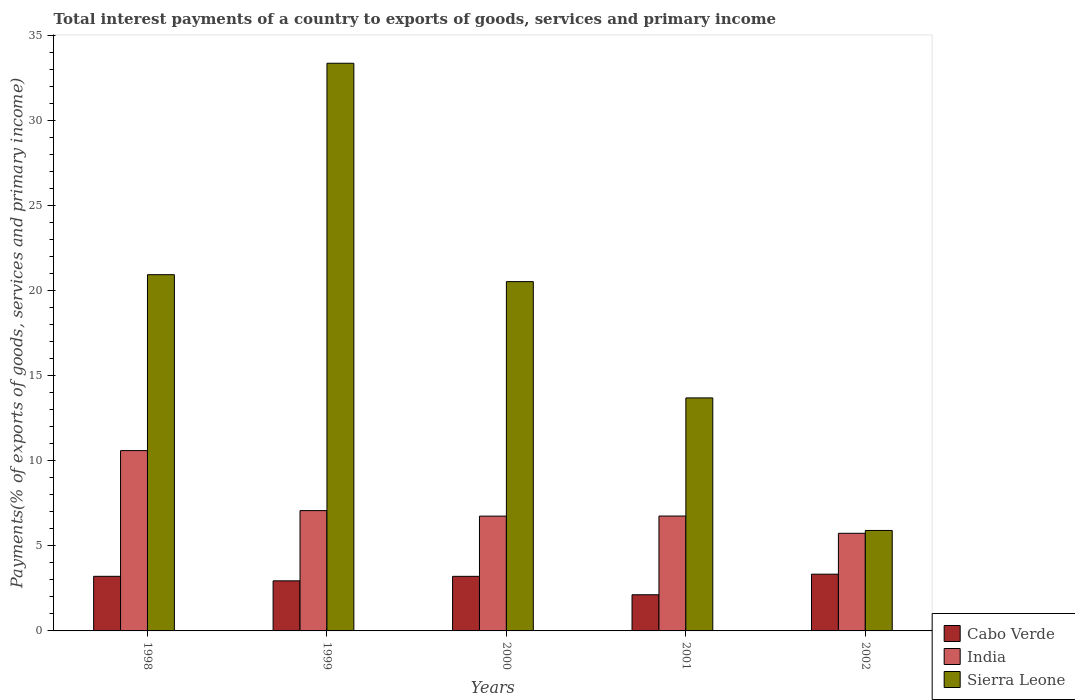How many different coloured bars are there?
Your answer should be very brief. 3. Are the number of bars per tick equal to the number of legend labels?
Ensure brevity in your answer.  Yes. Are the number of bars on each tick of the X-axis equal?
Provide a succinct answer. Yes. How many bars are there on the 3rd tick from the left?
Offer a very short reply. 3. How many bars are there on the 4th tick from the right?
Your answer should be very brief. 3. What is the total interest payments in Cabo Verde in 2002?
Your response must be concise. 3.34. Across all years, what is the maximum total interest payments in India?
Provide a succinct answer. 10.61. Across all years, what is the minimum total interest payments in India?
Your answer should be very brief. 5.74. In which year was the total interest payments in Sierra Leone maximum?
Your answer should be compact. 1999. In which year was the total interest payments in Sierra Leone minimum?
Make the answer very short. 2002. What is the total total interest payments in Sierra Leone in the graph?
Offer a very short reply. 94.5. What is the difference between the total interest payments in India in 2000 and that in 2002?
Offer a terse response. 1.01. What is the difference between the total interest payments in India in 2000 and the total interest payments in Cabo Verde in 1999?
Your answer should be very brief. 3.81. What is the average total interest payments in India per year?
Ensure brevity in your answer.  7.39. In the year 2001, what is the difference between the total interest payments in Sierra Leone and total interest payments in India?
Provide a short and direct response. 6.95. What is the ratio of the total interest payments in India in 2000 to that in 2002?
Provide a succinct answer. 1.18. What is the difference between the highest and the second highest total interest payments in Cabo Verde?
Ensure brevity in your answer.  0.13. What is the difference between the highest and the lowest total interest payments in Cabo Verde?
Your answer should be compact. 1.21. In how many years, is the total interest payments in Cabo Verde greater than the average total interest payments in Cabo Verde taken over all years?
Your answer should be very brief. 3. What does the 1st bar from the left in 1998 represents?
Offer a terse response. Cabo Verde. What does the 3rd bar from the right in 2001 represents?
Ensure brevity in your answer.  Cabo Verde. How many bars are there?
Ensure brevity in your answer.  15. Are all the bars in the graph horizontal?
Offer a terse response. No. How many years are there in the graph?
Ensure brevity in your answer.  5. What is the difference between two consecutive major ticks on the Y-axis?
Your answer should be very brief. 5. How are the legend labels stacked?
Give a very brief answer. Vertical. What is the title of the graph?
Provide a short and direct response. Total interest payments of a country to exports of goods, services and primary income. Does "Europe(developing only)" appear as one of the legend labels in the graph?
Make the answer very short. No. What is the label or title of the Y-axis?
Offer a very short reply. Payments(% of exports of goods, services and primary income). What is the Payments(% of exports of goods, services and primary income) in Cabo Verde in 1998?
Ensure brevity in your answer.  3.21. What is the Payments(% of exports of goods, services and primary income) in India in 1998?
Ensure brevity in your answer.  10.61. What is the Payments(% of exports of goods, services and primary income) in Sierra Leone in 1998?
Your answer should be very brief. 20.95. What is the Payments(% of exports of goods, services and primary income) of Cabo Verde in 1999?
Make the answer very short. 2.95. What is the Payments(% of exports of goods, services and primary income) of India in 1999?
Your response must be concise. 7.08. What is the Payments(% of exports of goods, services and primary income) of Sierra Leone in 1999?
Your response must be concise. 33.39. What is the Payments(% of exports of goods, services and primary income) in Cabo Verde in 2000?
Ensure brevity in your answer.  3.21. What is the Payments(% of exports of goods, services and primary income) in India in 2000?
Make the answer very short. 6.75. What is the Payments(% of exports of goods, services and primary income) of Sierra Leone in 2000?
Provide a short and direct response. 20.55. What is the Payments(% of exports of goods, services and primary income) of Cabo Verde in 2001?
Your answer should be compact. 2.13. What is the Payments(% of exports of goods, services and primary income) in India in 2001?
Your response must be concise. 6.76. What is the Payments(% of exports of goods, services and primary income) in Sierra Leone in 2001?
Your answer should be compact. 13.71. What is the Payments(% of exports of goods, services and primary income) of Cabo Verde in 2002?
Give a very brief answer. 3.34. What is the Payments(% of exports of goods, services and primary income) in India in 2002?
Provide a short and direct response. 5.74. What is the Payments(% of exports of goods, services and primary income) of Sierra Leone in 2002?
Give a very brief answer. 5.91. Across all years, what is the maximum Payments(% of exports of goods, services and primary income) in Cabo Verde?
Provide a succinct answer. 3.34. Across all years, what is the maximum Payments(% of exports of goods, services and primary income) of India?
Keep it short and to the point. 10.61. Across all years, what is the maximum Payments(% of exports of goods, services and primary income) of Sierra Leone?
Ensure brevity in your answer.  33.39. Across all years, what is the minimum Payments(% of exports of goods, services and primary income) of Cabo Verde?
Offer a terse response. 2.13. Across all years, what is the minimum Payments(% of exports of goods, services and primary income) in India?
Your answer should be very brief. 5.74. Across all years, what is the minimum Payments(% of exports of goods, services and primary income) of Sierra Leone?
Give a very brief answer. 5.91. What is the total Payments(% of exports of goods, services and primary income) in Cabo Verde in the graph?
Your response must be concise. 14.83. What is the total Payments(% of exports of goods, services and primary income) in India in the graph?
Provide a succinct answer. 36.94. What is the total Payments(% of exports of goods, services and primary income) in Sierra Leone in the graph?
Make the answer very short. 94.5. What is the difference between the Payments(% of exports of goods, services and primary income) in Cabo Verde in 1998 and that in 1999?
Your answer should be compact. 0.27. What is the difference between the Payments(% of exports of goods, services and primary income) of India in 1998 and that in 1999?
Your answer should be compact. 3.53. What is the difference between the Payments(% of exports of goods, services and primary income) in Sierra Leone in 1998 and that in 1999?
Provide a succinct answer. -12.44. What is the difference between the Payments(% of exports of goods, services and primary income) in Cabo Verde in 1998 and that in 2000?
Your answer should be very brief. 0. What is the difference between the Payments(% of exports of goods, services and primary income) in India in 1998 and that in 2000?
Make the answer very short. 3.85. What is the difference between the Payments(% of exports of goods, services and primary income) of Sierra Leone in 1998 and that in 2000?
Offer a very short reply. 0.41. What is the difference between the Payments(% of exports of goods, services and primary income) in Cabo Verde in 1998 and that in 2001?
Give a very brief answer. 1.08. What is the difference between the Payments(% of exports of goods, services and primary income) of India in 1998 and that in 2001?
Provide a short and direct response. 3.85. What is the difference between the Payments(% of exports of goods, services and primary income) in Sierra Leone in 1998 and that in 2001?
Your answer should be compact. 7.25. What is the difference between the Payments(% of exports of goods, services and primary income) in Cabo Verde in 1998 and that in 2002?
Provide a short and direct response. -0.13. What is the difference between the Payments(% of exports of goods, services and primary income) in India in 1998 and that in 2002?
Provide a succinct answer. 4.86. What is the difference between the Payments(% of exports of goods, services and primary income) in Sierra Leone in 1998 and that in 2002?
Give a very brief answer. 15.05. What is the difference between the Payments(% of exports of goods, services and primary income) in Cabo Verde in 1999 and that in 2000?
Offer a very short reply. -0.26. What is the difference between the Payments(% of exports of goods, services and primary income) in India in 1999 and that in 2000?
Provide a succinct answer. 0.32. What is the difference between the Payments(% of exports of goods, services and primary income) in Sierra Leone in 1999 and that in 2000?
Provide a succinct answer. 12.84. What is the difference between the Payments(% of exports of goods, services and primary income) of Cabo Verde in 1999 and that in 2001?
Offer a terse response. 0.82. What is the difference between the Payments(% of exports of goods, services and primary income) in India in 1999 and that in 2001?
Give a very brief answer. 0.32. What is the difference between the Payments(% of exports of goods, services and primary income) in Sierra Leone in 1999 and that in 2001?
Your answer should be compact. 19.68. What is the difference between the Payments(% of exports of goods, services and primary income) in Cabo Verde in 1999 and that in 2002?
Your answer should be compact. -0.39. What is the difference between the Payments(% of exports of goods, services and primary income) of India in 1999 and that in 2002?
Provide a succinct answer. 1.33. What is the difference between the Payments(% of exports of goods, services and primary income) of Sierra Leone in 1999 and that in 2002?
Offer a very short reply. 27.48. What is the difference between the Payments(% of exports of goods, services and primary income) in Cabo Verde in 2000 and that in 2001?
Your answer should be very brief. 1.08. What is the difference between the Payments(% of exports of goods, services and primary income) of India in 2000 and that in 2001?
Make the answer very short. -0.01. What is the difference between the Payments(% of exports of goods, services and primary income) in Sierra Leone in 2000 and that in 2001?
Offer a very short reply. 6.84. What is the difference between the Payments(% of exports of goods, services and primary income) of Cabo Verde in 2000 and that in 2002?
Ensure brevity in your answer.  -0.13. What is the difference between the Payments(% of exports of goods, services and primary income) of Sierra Leone in 2000 and that in 2002?
Your response must be concise. 14.64. What is the difference between the Payments(% of exports of goods, services and primary income) in Cabo Verde in 2001 and that in 2002?
Offer a very short reply. -1.21. What is the difference between the Payments(% of exports of goods, services and primary income) of Sierra Leone in 2001 and that in 2002?
Make the answer very short. 7.8. What is the difference between the Payments(% of exports of goods, services and primary income) of Cabo Verde in 1998 and the Payments(% of exports of goods, services and primary income) of India in 1999?
Provide a succinct answer. -3.86. What is the difference between the Payments(% of exports of goods, services and primary income) of Cabo Verde in 1998 and the Payments(% of exports of goods, services and primary income) of Sierra Leone in 1999?
Offer a very short reply. -30.18. What is the difference between the Payments(% of exports of goods, services and primary income) of India in 1998 and the Payments(% of exports of goods, services and primary income) of Sierra Leone in 1999?
Give a very brief answer. -22.78. What is the difference between the Payments(% of exports of goods, services and primary income) of Cabo Verde in 1998 and the Payments(% of exports of goods, services and primary income) of India in 2000?
Make the answer very short. -3.54. What is the difference between the Payments(% of exports of goods, services and primary income) of Cabo Verde in 1998 and the Payments(% of exports of goods, services and primary income) of Sierra Leone in 2000?
Provide a short and direct response. -17.33. What is the difference between the Payments(% of exports of goods, services and primary income) of India in 1998 and the Payments(% of exports of goods, services and primary income) of Sierra Leone in 2000?
Make the answer very short. -9.94. What is the difference between the Payments(% of exports of goods, services and primary income) of Cabo Verde in 1998 and the Payments(% of exports of goods, services and primary income) of India in 2001?
Your response must be concise. -3.55. What is the difference between the Payments(% of exports of goods, services and primary income) of Cabo Verde in 1998 and the Payments(% of exports of goods, services and primary income) of Sierra Leone in 2001?
Ensure brevity in your answer.  -10.49. What is the difference between the Payments(% of exports of goods, services and primary income) of India in 1998 and the Payments(% of exports of goods, services and primary income) of Sierra Leone in 2001?
Make the answer very short. -3.1. What is the difference between the Payments(% of exports of goods, services and primary income) of Cabo Verde in 1998 and the Payments(% of exports of goods, services and primary income) of India in 2002?
Make the answer very short. -2.53. What is the difference between the Payments(% of exports of goods, services and primary income) in Cabo Verde in 1998 and the Payments(% of exports of goods, services and primary income) in Sierra Leone in 2002?
Provide a succinct answer. -2.7. What is the difference between the Payments(% of exports of goods, services and primary income) of India in 1998 and the Payments(% of exports of goods, services and primary income) of Sierra Leone in 2002?
Offer a very short reply. 4.7. What is the difference between the Payments(% of exports of goods, services and primary income) in Cabo Verde in 1999 and the Payments(% of exports of goods, services and primary income) in India in 2000?
Keep it short and to the point. -3.81. What is the difference between the Payments(% of exports of goods, services and primary income) of Cabo Verde in 1999 and the Payments(% of exports of goods, services and primary income) of Sierra Leone in 2000?
Give a very brief answer. -17.6. What is the difference between the Payments(% of exports of goods, services and primary income) of India in 1999 and the Payments(% of exports of goods, services and primary income) of Sierra Leone in 2000?
Ensure brevity in your answer.  -13.47. What is the difference between the Payments(% of exports of goods, services and primary income) in Cabo Verde in 1999 and the Payments(% of exports of goods, services and primary income) in India in 2001?
Your response must be concise. -3.81. What is the difference between the Payments(% of exports of goods, services and primary income) of Cabo Verde in 1999 and the Payments(% of exports of goods, services and primary income) of Sierra Leone in 2001?
Give a very brief answer. -10.76. What is the difference between the Payments(% of exports of goods, services and primary income) in India in 1999 and the Payments(% of exports of goods, services and primary income) in Sierra Leone in 2001?
Make the answer very short. -6.63. What is the difference between the Payments(% of exports of goods, services and primary income) of Cabo Verde in 1999 and the Payments(% of exports of goods, services and primary income) of India in 2002?
Make the answer very short. -2.8. What is the difference between the Payments(% of exports of goods, services and primary income) of Cabo Verde in 1999 and the Payments(% of exports of goods, services and primary income) of Sierra Leone in 2002?
Give a very brief answer. -2.96. What is the difference between the Payments(% of exports of goods, services and primary income) in India in 1999 and the Payments(% of exports of goods, services and primary income) in Sierra Leone in 2002?
Your answer should be compact. 1.17. What is the difference between the Payments(% of exports of goods, services and primary income) of Cabo Verde in 2000 and the Payments(% of exports of goods, services and primary income) of India in 2001?
Offer a terse response. -3.55. What is the difference between the Payments(% of exports of goods, services and primary income) in Cabo Verde in 2000 and the Payments(% of exports of goods, services and primary income) in Sierra Leone in 2001?
Ensure brevity in your answer.  -10.49. What is the difference between the Payments(% of exports of goods, services and primary income) in India in 2000 and the Payments(% of exports of goods, services and primary income) in Sierra Leone in 2001?
Keep it short and to the point. -6.95. What is the difference between the Payments(% of exports of goods, services and primary income) in Cabo Verde in 2000 and the Payments(% of exports of goods, services and primary income) in India in 2002?
Offer a very short reply. -2.53. What is the difference between the Payments(% of exports of goods, services and primary income) of Cabo Verde in 2000 and the Payments(% of exports of goods, services and primary income) of Sierra Leone in 2002?
Your response must be concise. -2.7. What is the difference between the Payments(% of exports of goods, services and primary income) in India in 2000 and the Payments(% of exports of goods, services and primary income) in Sierra Leone in 2002?
Provide a short and direct response. 0.84. What is the difference between the Payments(% of exports of goods, services and primary income) in Cabo Verde in 2001 and the Payments(% of exports of goods, services and primary income) in India in 2002?
Provide a short and direct response. -3.62. What is the difference between the Payments(% of exports of goods, services and primary income) in Cabo Verde in 2001 and the Payments(% of exports of goods, services and primary income) in Sierra Leone in 2002?
Provide a succinct answer. -3.78. What is the difference between the Payments(% of exports of goods, services and primary income) in India in 2001 and the Payments(% of exports of goods, services and primary income) in Sierra Leone in 2002?
Provide a short and direct response. 0.85. What is the average Payments(% of exports of goods, services and primary income) of Cabo Verde per year?
Offer a terse response. 2.97. What is the average Payments(% of exports of goods, services and primary income) in India per year?
Keep it short and to the point. 7.39. What is the average Payments(% of exports of goods, services and primary income) of Sierra Leone per year?
Ensure brevity in your answer.  18.9. In the year 1998, what is the difference between the Payments(% of exports of goods, services and primary income) of Cabo Verde and Payments(% of exports of goods, services and primary income) of India?
Provide a short and direct response. -7.39. In the year 1998, what is the difference between the Payments(% of exports of goods, services and primary income) in Cabo Verde and Payments(% of exports of goods, services and primary income) in Sierra Leone?
Your answer should be very brief. -17.74. In the year 1998, what is the difference between the Payments(% of exports of goods, services and primary income) of India and Payments(% of exports of goods, services and primary income) of Sierra Leone?
Make the answer very short. -10.35. In the year 1999, what is the difference between the Payments(% of exports of goods, services and primary income) in Cabo Verde and Payments(% of exports of goods, services and primary income) in India?
Ensure brevity in your answer.  -4.13. In the year 1999, what is the difference between the Payments(% of exports of goods, services and primary income) of Cabo Verde and Payments(% of exports of goods, services and primary income) of Sierra Leone?
Ensure brevity in your answer.  -30.44. In the year 1999, what is the difference between the Payments(% of exports of goods, services and primary income) in India and Payments(% of exports of goods, services and primary income) in Sierra Leone?
Your response must be concise. -26.31. In the year 2000, what is the difference between the Payments(% of exports of goods, services and primary income) in Cabo Verde and Payments(% of exports of goods, services and primary income) in India?
Your response must be concise. -3.54. In the year 2000, what is the difference between the Payments(% of exports of goods, services and primary income) of Cabo Verde and Payments(% of exports of goods, services and primary income) of Sierra Leone?
Your answer should be compact. -17.34. In the year 2000, what is the difference between the Payments(% of exports of goods, services and primary income) in India and Payments(% of exports of goods, services and primary income) in Sierra Leone?
Provide a succinct answer. -13.79. In the year 2001, what is the difference between the Payments(% of exports of goods, services and primary income) in Cabo Verde and Payments(% of exports of goods, services and primary income) in India?
Your response must be concise. -4.63. In the year 2001, what is the difference between the Payments(% of exports of goods, services and primary income) in Cabo Verde and Payments(% of exports of goods, services and primary income) in Sierra Leone?
Offer a very short reply. -11.58. In the year 2001, what is the difference between the Payments(% of exports of goods, services and primary income) in India and Payments(% of exports of goods, services and primary income) in Sierra Leone?
Your answer should be very brief. -6.95. In the year 2002, what is the difference between the Payments(% of exports of goods, services and primary income) in Cabo Verde and Payments(% of exports of goods, services and primary income) in India?
Offer a very short reply. -2.41. In the year 2002, what is the difference between the Payments(% of exports of goods, services and primary income) of Cabo Verde and Payments(% of exports of goods, services and primary income) of Sierra Leone?
Your response must be concise. -2.57. In the year 2002, what is the difference between the Payments(% of exports of goods, services and primary income) of India and Payments(% of exports of goods, services and primary income) of Sierra Leone?
Ensure brevity in your answer.  -0.17. What is the ratio of the Payments(% of exports of goods, services and primary income) in Cabo Verde in 1998 to that in 1999?
Give a very brief answer. 1.09. What is the ratio of the Payments(% of exports of goods, services and primary income) of India in 1998 to that in 1999?
Your answer should be very brief. 1.5. What is the ratio of the Payments(% of exports of goods, services and primary income) in Sierra Leone in 1998 to that in 1999?
Your answer should be very brief. 0.63. What is the ratio of the Payments(% of exports of goods, services and primary income) of Cabo Verde in 1998 to that in 2000?
Your answer should be compact. 1. What is the ratio of the Payments(% of exports of goods, services and primary income) of India in 1998 to that in 2000?
Keep it short and to the point. 1.57. What is the ratio of the Payments(% of exports of goods, services and primary income) of Sierra Leone in 1998 to that in 2000?
Your response must be concise. 1.02. What is the ratio of the Payments(% of exports of goods, services and primary income) of Cabo Verde in 1998 to that in 2001?
Offer a terse response. 1.51. What is the ratio of the Payments(% of exports of goods, services and primary income) of India in 1998 to that in 2001?
Offer a very short reply. 1.57. What is the ratio of the Payments(% of exports of goods, services and primary income) of Sierra Leone in 1998 to that in 2001?
Offer a very short reply. 1.53. What is the ratio of the Payments(% of exports of goods, services and primary income) of Cabo Verde in 1998 to that in 2002?
Provide a short and direct response. 0.96. What is the ratio of the Payments(% of exports of goods, services and primary income) in India in 1998 to that in 2002?
Your answer should be very brief. 1.85. What is the ratio of the Payments(% of exports of goods, services and primary income) of Sierra Leone in 1998 to that in 2002?
Keep it short and to the point. 3.55. What is the ratio of the Payments(% of exports of goods, services and primary income) of Cabo Verde in 1999 to that in 2000?
Your answer should be compact. 0.92. What is the ratio of the Payments(% of exports of goods, services and primary income) in India in 1999 to that in 2000?
Your response must be concise. 1.05. What is the ratio of the Payments(% of exports of goods, services and primary income) of Sierra Leone in 1999 to that in 2000?
Keep it short and to the point. 1.63. What is the ratio of the Payments(% of exports of goods, services and primary income) in Cabo Verde in 1999 to that in 2001?
Ensure brevity in your answer.  1.38. What is the ratio of the Payments(% of exports of goods, services and primary income) in India in 1999 to that in 2001?
Your answer should be very brief. 1.05. What is the ratio of the Payments(% of exports of goods, services and primary income) in Sierra Leone in 1999 to that in 2001?
Ensure brevity in your answer.  2.44. What is the ratio of the Payments(% of exports of goods, services and primary income) of Cabo Verde in 1999 to that in 2002?
Make the answer very short. 0.88. What is the ratio of the Payments(% of exports of goods, services and primary income) in India in 1999 to that in 2002?
Your response must be concise. 1.23. What is the ratio of the Payments(% of exports of goods, services and primary income) in Sierra Leone in 1999 to that in 2002?
Your response must be concise. 5.65. What is the ratio of the Payments(% of exports of goods, services and primary income) of Cabo Verde in 2000 to that in 2001?
Provide a short and direct response. 1.51. What is the ratio of the Payments(% of exports of goods, services and primary income) in India in 2000 to that in 2001?
Offer a very short reply. 1. What is the ratio of the Payments(% of exports of goods, services and primary income) of Sierra Leone in 2000 to that in 2001?
Provide a short and direct response. 1.5. What is the ratio of the Payments(% of exports of goods, services and primary income) in India in 2000 to that in 2002?
Offer a very short reply. 1.18. What is the ratio of the Payments(% of exports of goods, services and primary income) in Sierra Leone in 2000 to that in 2002?
Your answer should be compact. 3.48. What is the ratio of the Payments(% of exports of goods, services and primary income) in Cabo Verde in 2001 to that in 2002?
Your answer should be compact. 0.64. What is the ratio of the Payments(% of exports of goods, services and primary income) of India in 2001 to that in 2002?
Keep it short and to the point. 1.18. What is the ratio of the Payments(% of exports of goods, services and primary income) of Sierra Leone in 2001 to that in 2002?
Your response must be concise. 2.32. What is the difference between the highest and the second highest Payments(% of exports of goods, services and primary income) of Cabo Verde?
Offer a very short reply. 0.13. What is the difference between the highest and the second highest Payments(% of exports of goods, services and primary income) of India?
Your answer should be compact. 3.53. What is the difference between the highest and the second highest Payments(% of exports of goods, services and primary income) in Sierra Leone?
Provide a short and direct response. 12.44. What is the difference between the highest and the lowest Payments(% of exports of goods, services and primary income) in Cabo Verde?
Make the answer very short. 1.21. What is the difference between the highest and the lowest Payments(% of exports of goods, services and primary income) of India?
Give a very brief answer. 4.86. What is the difference between the highest and the lowest Payments(% of exports of goods, services and primary income) in Sierra Leone?
Offer a very short reply. 27.48. 